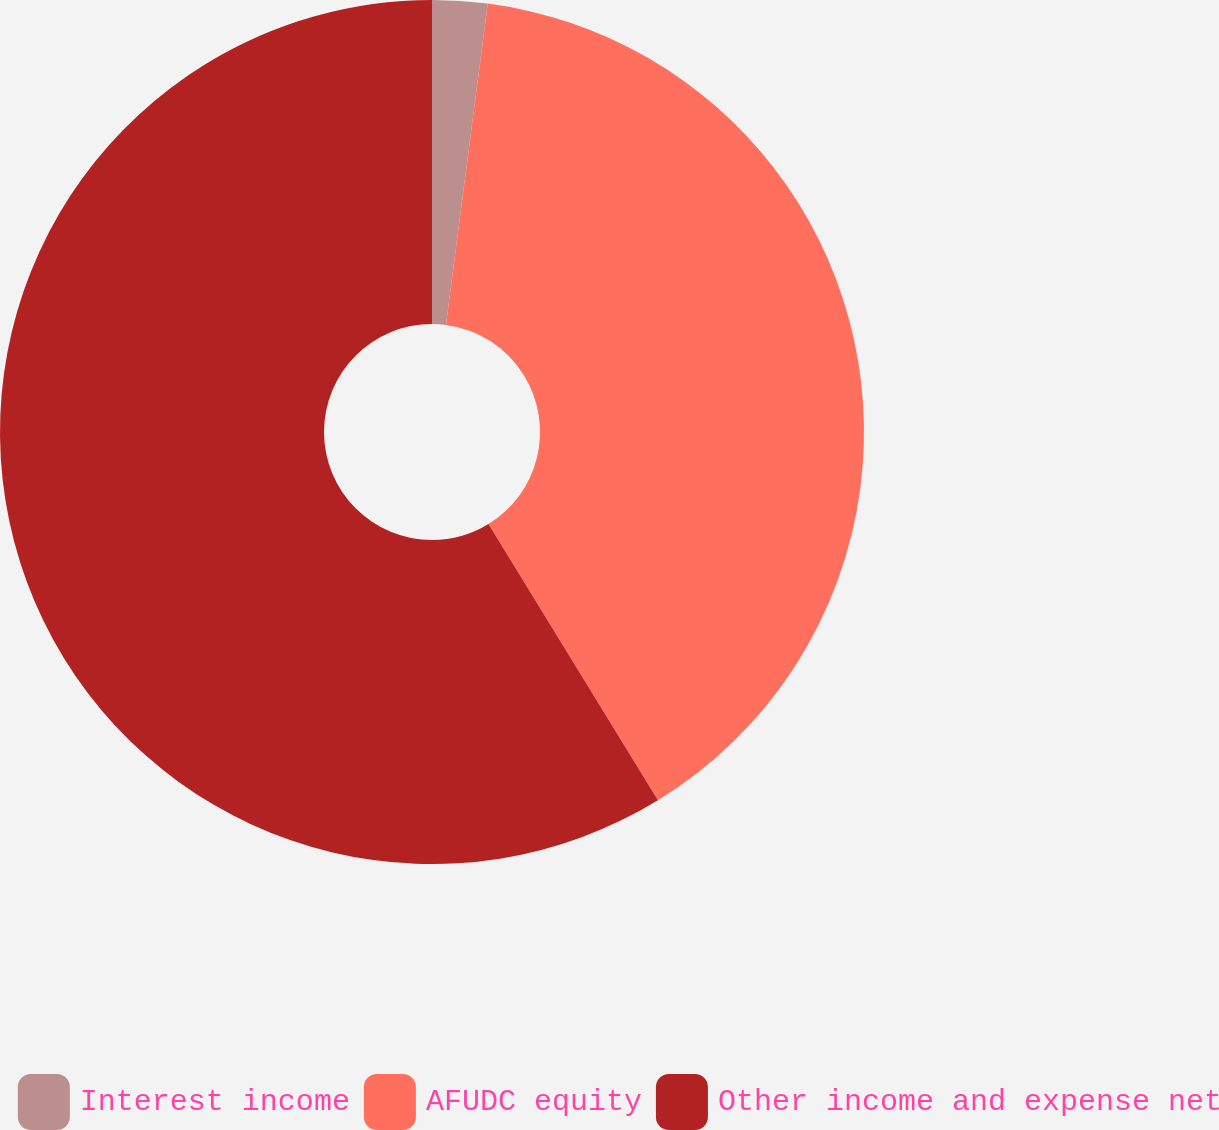Convert chart to OTSL. <chart><loc_0><loc_0><loc_500><loc_500><pie_chart><fcel>Interest income<fcel>AFUDC equity<fcel>Other income and expense net<nl><fcel>2.06%<fcel>39.18%<fcel>58.76%<nl></chart> 